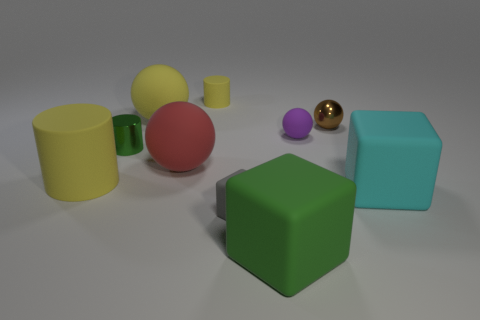Subtract all cylinders. How many objects are left? 7 Subtract 0 blue blocks. How many objects are left? 10 Subtract all yellow shiny things. Subtract all small objects. How many objects are left? 5 Add 7 matte cylinders. How many matte cylinders are left? 9 Add 2 big green objects. How many big green objects exist? 3 